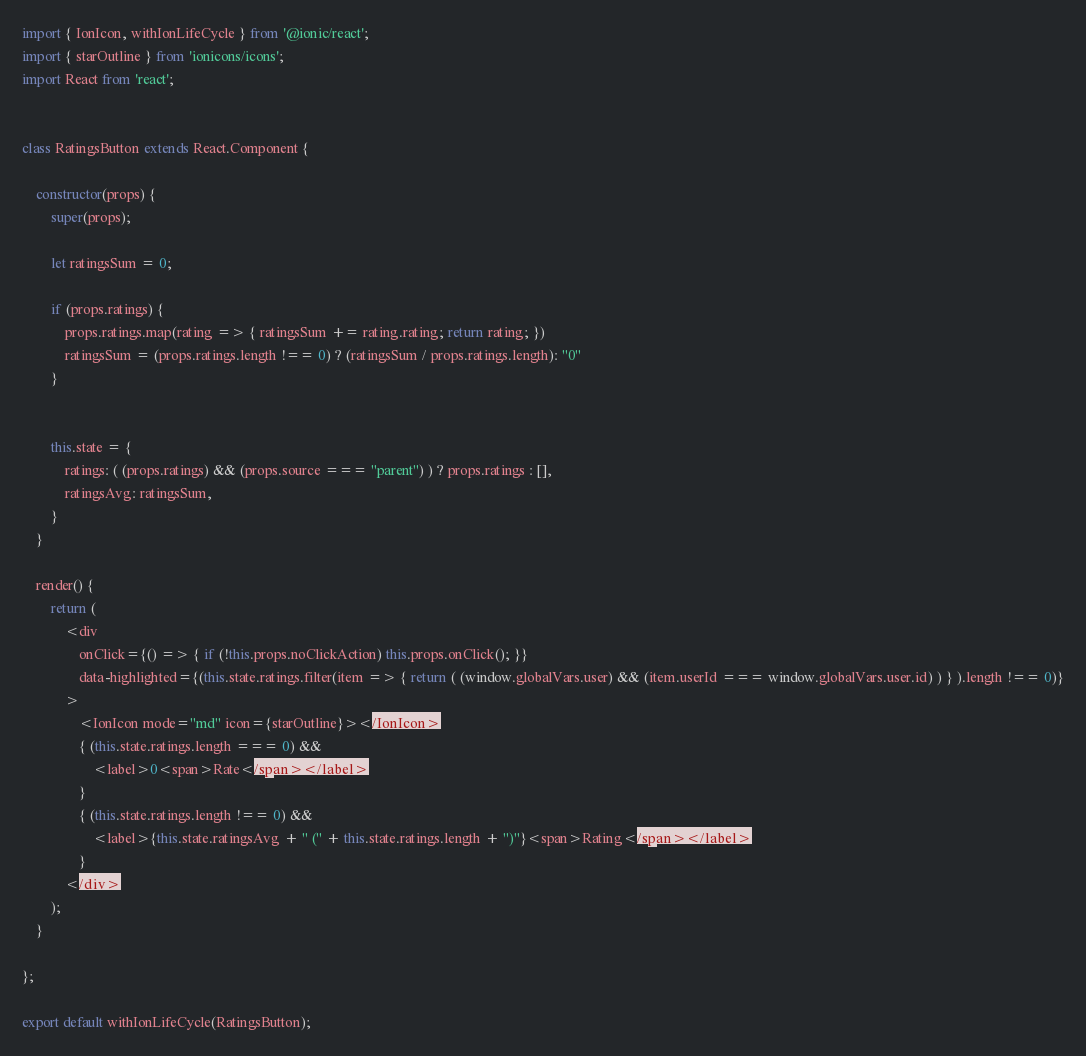<code> <loc_0><loc_0><loc_500><loc_500><_JavaScript_>import { IonIcon, withIonLifeCycle } from '@ionic/react';
import { starOutline } from 'ionicons/icons';
import React from 'react';


class RatingsButton extends React.Component {

    constructor(props) {
        super(props);

        let ratingsSum = 0;

        if (props.ratings) {
            props.ratings.map(rating => { ratingsSum += rating.rating; return rating; })
            ratingsSum = (props.ratings.length !== 0) ? (ratingsSum / props.ratings.length): "0"
        }


        this.state = {
            ratings: ( (props.ratings) && (props.source === "parent") ) ? props.ratings : [],
            ratingsAvg: ratingsSum,
        }
    }

    render() {
        return (
            <div
                onClick={() => { if (!this.props.noClickAction) this.props.onClick(); }}
                data-highlighted={(this.state.ratings.filter(item => { return ( (window.globalVars.user) && (item.userId === window.globalVars.user.id) ) } ).length !== 0)}
            >
                <IonIcon mode="md" icon={starOutline}></IonIcon>
                { (this.state.ratings.length === 0) &&
                    <label>0<span>Rate</span></label>
                }
                { (this.state.ratings.length !== 0) &&
                    <label>{this.state.ratingsAvg + " (" + this.state.ratings.length + ")"}<span>Rating</span></label>
                }
            </div>
        );
    }

};

export default withIonLifeCycle(RatingsButton);
</code> 